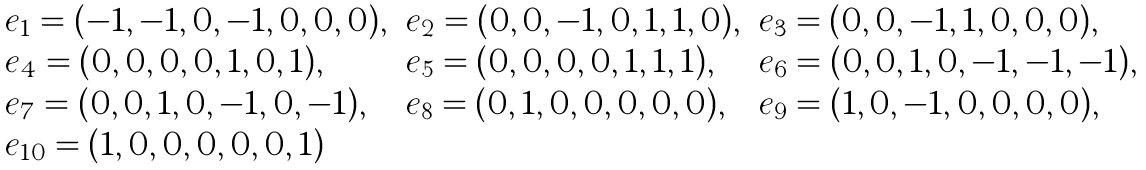<formula> <loc_0><loc_0><loc_500><loc_500>\begin{array} { l l l } e _ { 1 } = ( - 1 , - 1 , 0 , - 1 , 0 , 0 , 0 ) , & e _ { 2 } = ( 0 , 0 , - 1 , 0 , 1 , 1 , 0 ) , & e _ { 3 } = ( 0 , 0 , - 1 , 1 , 0 , 0 , 0 ) , \\ e _ { 4 } = ( 0 , 0 , 0 , 0 , 1 , 0 , 1 ) , & e _ { 5 } = ( 0 , 0 , 0 , 0 , 1 , 1 , 1 ) , & e _ { 6 } = ( 0 , 0 , 1 , 0 , - 1 , - 1 , - 1 ) , \\ e _ { 7 } = ( 0 , 0 , 1 , 0 , - 1 , 0 , - 1 ) , & e _ { 8 } = ( 0 , 1 , 0 , 0 , 0 , 0 , 0 ) , & e _ { 9 } = ( 1 , 0 , - 1 , 0 , 0 , 0 , 0 ) , \\ e _ { 1 0 } = ( 1 , 0 , 0 , 0 , 0 , 0 , 1 ) & & \end{array}</formula> 